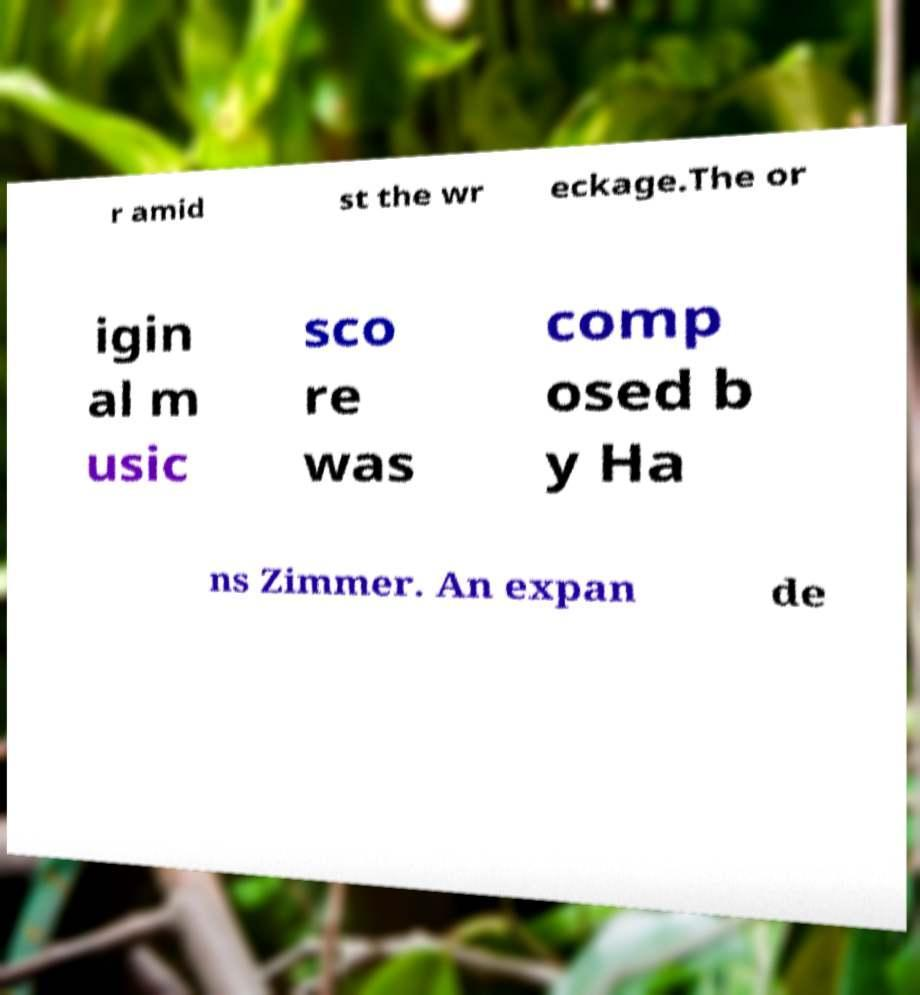Could you extract and type out the text from this image? r amid st the wr eckage.The or igin al m usic sco re was comp osed b y Ha ns Zimmer. An expan de 